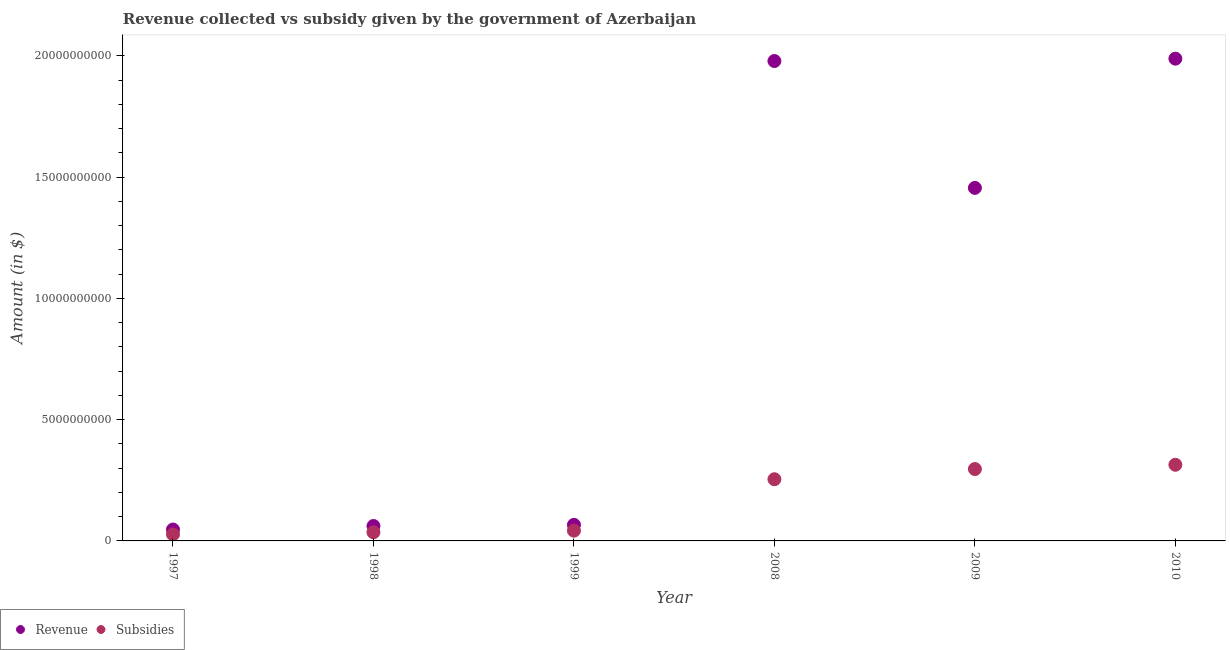How many different coloured dotlines are there?
Your answer should be very brief. 2. Is the number of dotlines equal to the number of legend labels?
Offer a very short reply. Yes. What is the amount of subsidies given in 1999?
Your answer should be compact. 4.23e+08. Across all years, what is the maximum amount of revenue collected?
Keep it short and to the point. 1.99e+1. Across all years, what is the minimum amount of subsidies given?
Your answer should be compact. 2.69e+08. What is the total amount of subsidies given in the graph?
Offer a terse response. 9.70e+09. What is the difference between the amount of subsidies given in 1999 and that in 2009?
Keep it short and to the point. -2.54e+09. What is the difference between the amount of subsidies given in 2010 and the amount of revenue collected in 2008?
Make the answer very short. -1.66e+1. What is the average amount of subsidies given per year?
Your response must be concise. 1.62e+09. In the year 2009, what is the difference between the amount of revenue collected and amount of subsidies given?
Your answer should be very brief. 1.16e+1. What is the ratio of the amount of revenue collected in 2008 to that in 2010?
Offer a terse response. 1. Is the amount of revenue collected in 1999 less than that in 2008?
Provide a short and direct response. Yes. Is the difference between the amount of subsidies given in 1997 and 2008 greater than the difference between the amount of revenue collected in 1997 and 2008?
Provide a short and direct response. Yes. What is the difference between the highest and the second highest amount of subsidies given?
Offer a very short reply. 1.76e+08. What is the difference between the highest and the lowest amount of revenue collected?
Ensure brevity in your answer.  1.94e+1. In how many years, is the amount of revenue collected greater than the average amount of revenue collected taken over all years?
Ensure brevity in your answer.  3. Is the amount of revenue collected strictly less than the amount of subsidies given over the years?
Provide a succinct answer. No. How many years are there in the graph?
Give a very brief answer. 6. Are the values on the major ticks of Y-axis written in scientific E-notation?
Provide a succinct answer. No. Does the graph contain any zero values?
Offer a very short reply. No. Does the graph contain grids?
Offer a terse response. No. How many legend labels are there?
Keep it short and to the point. 2. What is the title of the graph?
Your answer should be compact. Revenue collected vs subsidy given by the government of Azerbaijan. Does "Ages 15-24" appear as one of the legend labels in the graph?
Give a very brief answer. No. What is the label or title of the X-axis?
Give a very brief answer. Year. What is the label or title of the Y-axis?
Keep it short and to the point. Amount (in $). What is the Amount (in $) in Revenue in 1997?
Your answer should be very brief. 4.70e+08. What is the Amount (in $) in Subsidies in 1997?
Offer a terse response. 2.69e+08. What is the Amount (in $) of Revenue in 1998?
Provide a succinct answer. 6.15e+08. What is the Amount (in $) of Subsidies in 1998?
Your answer should be compact. 3.57e+08. What is the Amount (in $) of Revenue in 1999?
Provide a succinct answer. 6.63e+08. What is the Amount (in $) of Subsidies in 1999?
Offer a terse response. 4.23e+08. What is the Amount (in $) of Revenue in 2008?
Offer a terse response. 1.98e+1. What is the Amount (in $) of Subsidies in 2008?
Ensure brevity in your answer.  2.54e+09. What is the Amount (in $) in Revenue in 2009?
Your response must be concise. 1.46e+1. What is the Amount (in $) in Subsidies in 2009?
Your answer should be compact. 2.96e+09. What is the Amount (in $) in Revenue in 2010?
Your response must be concise. 1.99e+1. What is the Amount (in $) in Subsidies in 2010?
Offer a very short reply. 3.14e+09. Across all years, what is the maximum Amount (in $) in Revenue?
Provide a succinct answer. 1.99e+1. Across all years, what is the maximum Amount (in $) in Subsidies?
Offer a very short reply. 3.14e+09. Across all years, what is the minimum Amount (in $) in Revenue?
Provide a short and direct response. 4.70e+08. Across all years, what is the minimum Amount (in $) of Subsidies?
Offer a very short reply. 2.69e+08. What is the total Amount (in $) of Revenue in the graph?
Your answer should be compact. 5.60e+1. What is the total Amount (in $) in Subsidies in the graph?
Ensure brevity in your answer.  9.70e+09. What is the difference between the Amount (in $) of Revenue in 1997 and that in 1998?
Provide a succinct answer. -1.45e+08. What is the difference between the Amount (in $) of Subsidies in 1997 and that in 1998?
Provide a short and direct response. -8.79e+07. What is the difference between the Amount (in $) of Revenue in 1997 and that in 1999?
Give a very brief answer. -1.93e+08. What is the difference between the Amount (in $) of Subsidies in 1997 and that in 1999?
Give a very brief answer. -1.53e+08. What is the difference between the Amount (in $) in Revenue in 1997 and that in 2008?
Provide a short and direct response. -1.93e+1. What is the difference between the Amount (in $) of Subsidies in 1997 and that in 2008?
Offer a terse response. -2.27e+09. What is the difference between the Amount (in $) in Revenue in 1997 and that in 2009?
Offer a very short reply. -1.41e+1. What is the difference between the Amount (in $) of Subsidies in 1997 and that in 2009?
Make the answer very short. -2.69e+09. What is the difference between the Amount (in $) in Revenue in 1997 and that in 2010?
Give a very brief answer. -1.94e+1. What is the difference between the Amount (in $) in Subsidies in 1997 and that in 2010?
Offer a terse response. -2.87e+09. What is the difference between the Amount (in $) of Revenue in 1998 and that in 1999?
Provide a succinct answer. -4.82e+07. What is the difference between the Amount (in $) in Subsidies in 1998 and that in 1999?
Your answer should be very brief. -6.55e+07. What is the difference between the Amount (in $) in Revenue in 1998 and that in 2008?
Offer a terse response. -1.92e+1. What is the difference between the Amount (in $) of Subsidies in 1998 and that in 2008?
Your answer should be compact. -2.19e+09. What is the difference between the Amount (in $) of Revenue in 1998 and that in 2009?
Your answer should be compact. -1.39e+1. What is the difference between the Amount (in $) of Subsidies in 1998 and that in 2009?
Provide a short and direct response. -2.61e+09. What is the difference between the Amount (in $) in Revenue in 1998 and that in 2010?
Provide a short and direct response. -1.93e+1. What is the difference between the Amount (in $) in Subsidies in 1998 and that in 2010?
Your answer should be compact. -2.78e+09. What is the difference between the Amount (in $) of Revenue in 1999 and that in 2008?
Your response must be concise. -1.91e+1. What is the difference between the Amount (in $) in Subsidies in 1999 and that in 2008?
Make the answer very short. -2.12e+09. What is the difference between the Amount (in $) in Revenue in 1999 and that in 2009?
Provide a succinct answer. -1.39e+1. What is the difference between the Amount (in $) of Subsidies in 1999 and that in 2009?
Provide a succinct answer. -2.54e+09. What is the difference between the Amount (in $) in Revenue in 1999 and that in 2010?
Give a very brief answer. -1.92e+1. What is the difference between the Amount (in $) in Subsidies in 1999 and that in 2010?
Your response must be concise. -2.72e+09. What is the difference between the Amount (in $) in Revenue in 2008 and that in 2009?
Give a very brief answer. 5.23e+09. What is the difference between the Amount (in $) of Subsidies in 2008 and that in 2009?
Your response must be concise. -4.20e+08. What is the difference between the Amount (in $) in Revenue in 2008 and that in 2010?
Provide a short and direct response. -9.75e+07. What is the difference between the Amount (in $) of Subsidies in 2008 and that in 2010?
Offer a very short reply. -5.96e+08. What is the difference between the Amount (in $) of Revenue in 2009 and that in 2010?
Your answer should be very brief. -5.33e+09. What is the difference between the Amount (in $) of Subsidies in 2009 and that in 2010?
Make the answer very short. -1.76e+08. What is the difference between the Amount (in $) in Revenue in 1997 and the Amount (in $) in Subsidies in 1998?
Provide a succinct answer. 1.13e+08. What is the difference between the Amount (in $) of Revenue in 1997 and the Amount (in $) of Subsidies in 1999?
Offer a very short reply. 4.75e+07. What is the difference between the Amount (in $) in Revenue in 1997 and the Amount (in $) in Subsidies in 2008?
Keep it short and to the point. -2.07e+09. What is the difference between the Amount (in $) in Revenue in 1997 and the Amount (in $) in Subsidies in 2009?
Provide a succinct answer. -2.49e+09. What is the difference between the Amount (in $) of Revenue in 1997 and the Amount (in $) of Subsidies in 2010?
Make the answer very short. -2.67e+09. What is the difference between the Amount (in $) of Revenue in 1998 and the Amount (in $) of Subsidies in 1999?
Keep it short and to the point. 1.93e+08. What is the difference between the Amount (in $) of Revenue in 1998 and the Amount (in $) of Subsidies in 2008?
Give a very brief answer. -1.93e+09. What is the difference between the Amount (in $) in Revenue in 1998 and the Amount (in $) in Subsidies in 2009?
Ensure brevity in your answer.  -2.35e+09. What is the difference between the Amount (in $) in Revenue in 1998 and the Amount (in $) in Subsidies in 2010?
Provide a short and direct response. -2.52e+09. What is the difference between the Amount (in $) in Revenue in 1999 and the Amount (in $) in Subsidies in 2008?
Offer a terse response. -1.88e+09. What is the difference between the Amount (in $) in Revenue in 1999 and the Amount (in $) in Subsidies in 2009?
Ensure brevity in your answer.  -2.30e+09. What is the difference between the Amount (in $) in Revenue in 1999 and the Amount (in $) in Subsidies in 2010?
Provide a short and direct response. -2.48e+09. What is the difference between the Amount (in $) of Revenue in 2008 and the Amount (in $) of Subsidies in 2009?
Offer a terse response. 1.68e+1. What is the difference between the Amount (in $) of Revenue in 2008 and the Amount (in $) of Subsidies in 2010?
Keep it short and to the point. 1.66e+1. What is the difference between the Amount (in $) in Revenue in 2009 and the Amount (in $) in Subsidies in 2010?
Your response must be concise. 1.14e+1. What is the average Amount (in $) in Revenue per year?
Provide a short and direct response. 9.33e+09. What is the average Amount (in $) in Subsidies per year?
Provide a short and direct response. 1.62e+09. In the year 1997, what is the difference between the Amount (in $) in Revenue and Amount (in $) in Subsidies?
Your response must be concise. 2.01e+08. In the year 1998, what is the difference between the Amount (in $) in Revenue and Amount (in $) in Subsidies?
Make the answer very short. 2.58e+08. In the year 1999, what is the difference between the Amount (in $) of Revenue and Amount (in $) of Subsidies?
Offer a very short reply. 2.41e+08. In the year 2008, what is the difference between the Amount (in $) in Revenue and Amount (in $) in Subsidies?
Your answer should be compact. 1.72e+1. In the year 2009, what is the difference between the Amount (in $) in Revenue and Amount (in $) in Subsidies?
Your answer should be compact. 1.16e+1. In the year 2010, what is the difference between the Amount (in $) of Revenue and Amount (in $) of Subsidies?
Your response must be concise. 1.67e+1. What is the ratio of the Amount (in $) of Revenue in 1997 to that in 1998?
Give a very brief answer. 0.76. What is the ratio of the Amount (in $) in Subsidies in 1997 to that in 1998?
Provide a short and direct response. 0.75. What is the ratio of the Amount (in $) of Revenue in 1997 to that in 1999?
Provide a succinct answer. 0.71. What is the ratio of the Amount (in $) in Subsidies in 1997 to that in 1999?
Your answer should be compact. 0.64. What is the ratio of the Amount (in $) of Revenue in 1997 to that in 2008?
Give a very brief answer. 0.02. What is the ratio of the Amount (in $) in Subsidies in 1997 to that in 2008?
Your response must be concise. 0.11. What is the ratio of the Amount (in $) of Revenue in 1997 to that in 2009?
Your answer should be compact. 0.03. What is the ratio of the Amount (in $) of Subsidies in 1997 to that in 2009?
Make the answer very short. 0.09. What is the ratio of the Amount (in $) in Revenue in 1997 to that in 2010?
Provide a short and direct response. 0.02. What is the ratio of the Amount (in $) of Subsidies in 1997 to that in 2010?
Your answer should be very brief. 0.09. What is the ratio of the Amount (in $) of Revenue in 1998 to that in 1999?
Provide a short and direct response. 0.93. What is the ratio of the Amount (in $) of Subsidies in 1998 to that in 1999?
Give a very brief answer. 0.85. What is the ratio of the Amount (in $) of Revenue in 1998 to that in 2008?
Your answer should be very brief. 0.03. What is the ratio of the Amount (in $) in Subsidies in 1998 to that in 2008?
Provide a short and direct response. 0.14. What is the ratio of the Amount (in $) in Revenue in 1998 to that in 2009?
Provide a short and direct response. 0.04. What is the ratio of the Amount (in $) in Subsidies in 1998 to that in 2009?
Offer a terse response. 0.12. What is the ratio of the Amount (in $) of Revenue in 1998 to that in 2010?
Your answer should be very brief. 0.03. What is the ratio of the Amount (in $) in Subsidies in 1998 to that in 2010?
Provide a short and direct response. 0.11. What is the ratio of the Amount (in $) of Revenue in 1999 to that in 2008?
Make the answer very short. 0.03. What is the ratio of the Amount (in $) of Subsidies in 1999 to that in 2008?
Offer a terse response. 0.17. What is the ratio of the Amount (in $) in Revenue in 1999 to that in 2009?
Make the answer very short. 0.05. What is the ratio of the Amount (in $) in Subsidies in 1999 to that in 2009?
Offer a very short reply. 0.14. What is the ratio of the Amount (in $) in Revenue in 1999 to that in 2010?
Your response must be concise. 0.03. What is the ratio of the Amount (in $) of Subsidies in 1999 to that in 2010?
Your answer should be compact. 0.13. What is the ratio of the Amount (in $) in Revenue in 2008 to that in 2009?
Your answer should be compact. 1.36. What is the ratio of the Amount (in $) of Subsidies in 2008 to that in 2009?
Give a very brief answer. 0.86. What is the ratio of the Amount (in $) of Subsidies in 2008 to that in 2010?
Your answer should be very brief. 0.81. What is the ratio of the Amount (in $) in Revenue in 2009 to that in 2010?
Make the answer very short. 0.73. What is the ratio of the Amount (in $) of Subsidies in 2009 to that in 2010?
Make the answer very short. 0.94. What is the difference between the highest and the second highest Amount (in $) in Revenue?
Offer a very short reply. 9.75e+07. What is the difference between the highest and the second highest Amount (in $) of Subsidies?
Your response must be concise. 1.76e+08. What is the difference between the highest and the lowest Amount (in $) of Revenue?
Your response must be concise. 1.94e+1. What is the difference between the highest and the lowest Amount (in $) in Subsidies?
Offer a very short reply. 2.87e+09. 